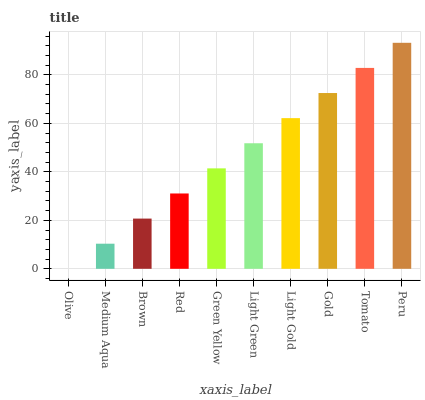Is Medium Aqua the minimum?
Answer yes or no. No. Is Medium Aqua the maximum?
Answer yes or no. No. Is Medium Aqua greater than Olive?
Answer yes or no. Yes. Is Olive less than Medium Aqua?
Answer yes or no. Yes. Is Olive greater than Medium Aqua?
Answer yes or no. No. Is Medium Aqua less than Olive?
Answer yes or no. No. Is Light Green the high median?
Answer yes or no. Yes. Is Green Yellow the low median?
Answer yes or no. Yes. Is Medium Aqua the high median?
Answer yes or no. No. Is Light Green the low median?
Answer yes or no. No. 